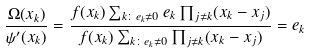<formula> <loc_0><loc_0><loc_500><loc_500>\frac { \Omega ( x _ { k } ) } { \psi ^ { \prime } ( x _ { k } ) } = \frac { f ( x _ { k } ) \sum _ { k \colon e _ { k } \neq 0 } e _ { k } \prod _ { j \neq k } ( x _ { k } - x _ { j } ) } { f ( x _ { k } ) \sum _ { k \colon e _ { k } \neq 0 } \prod _ { j \neq k } ( x _ { k } - x _ { j } ) } = e _ { k }</formula> 